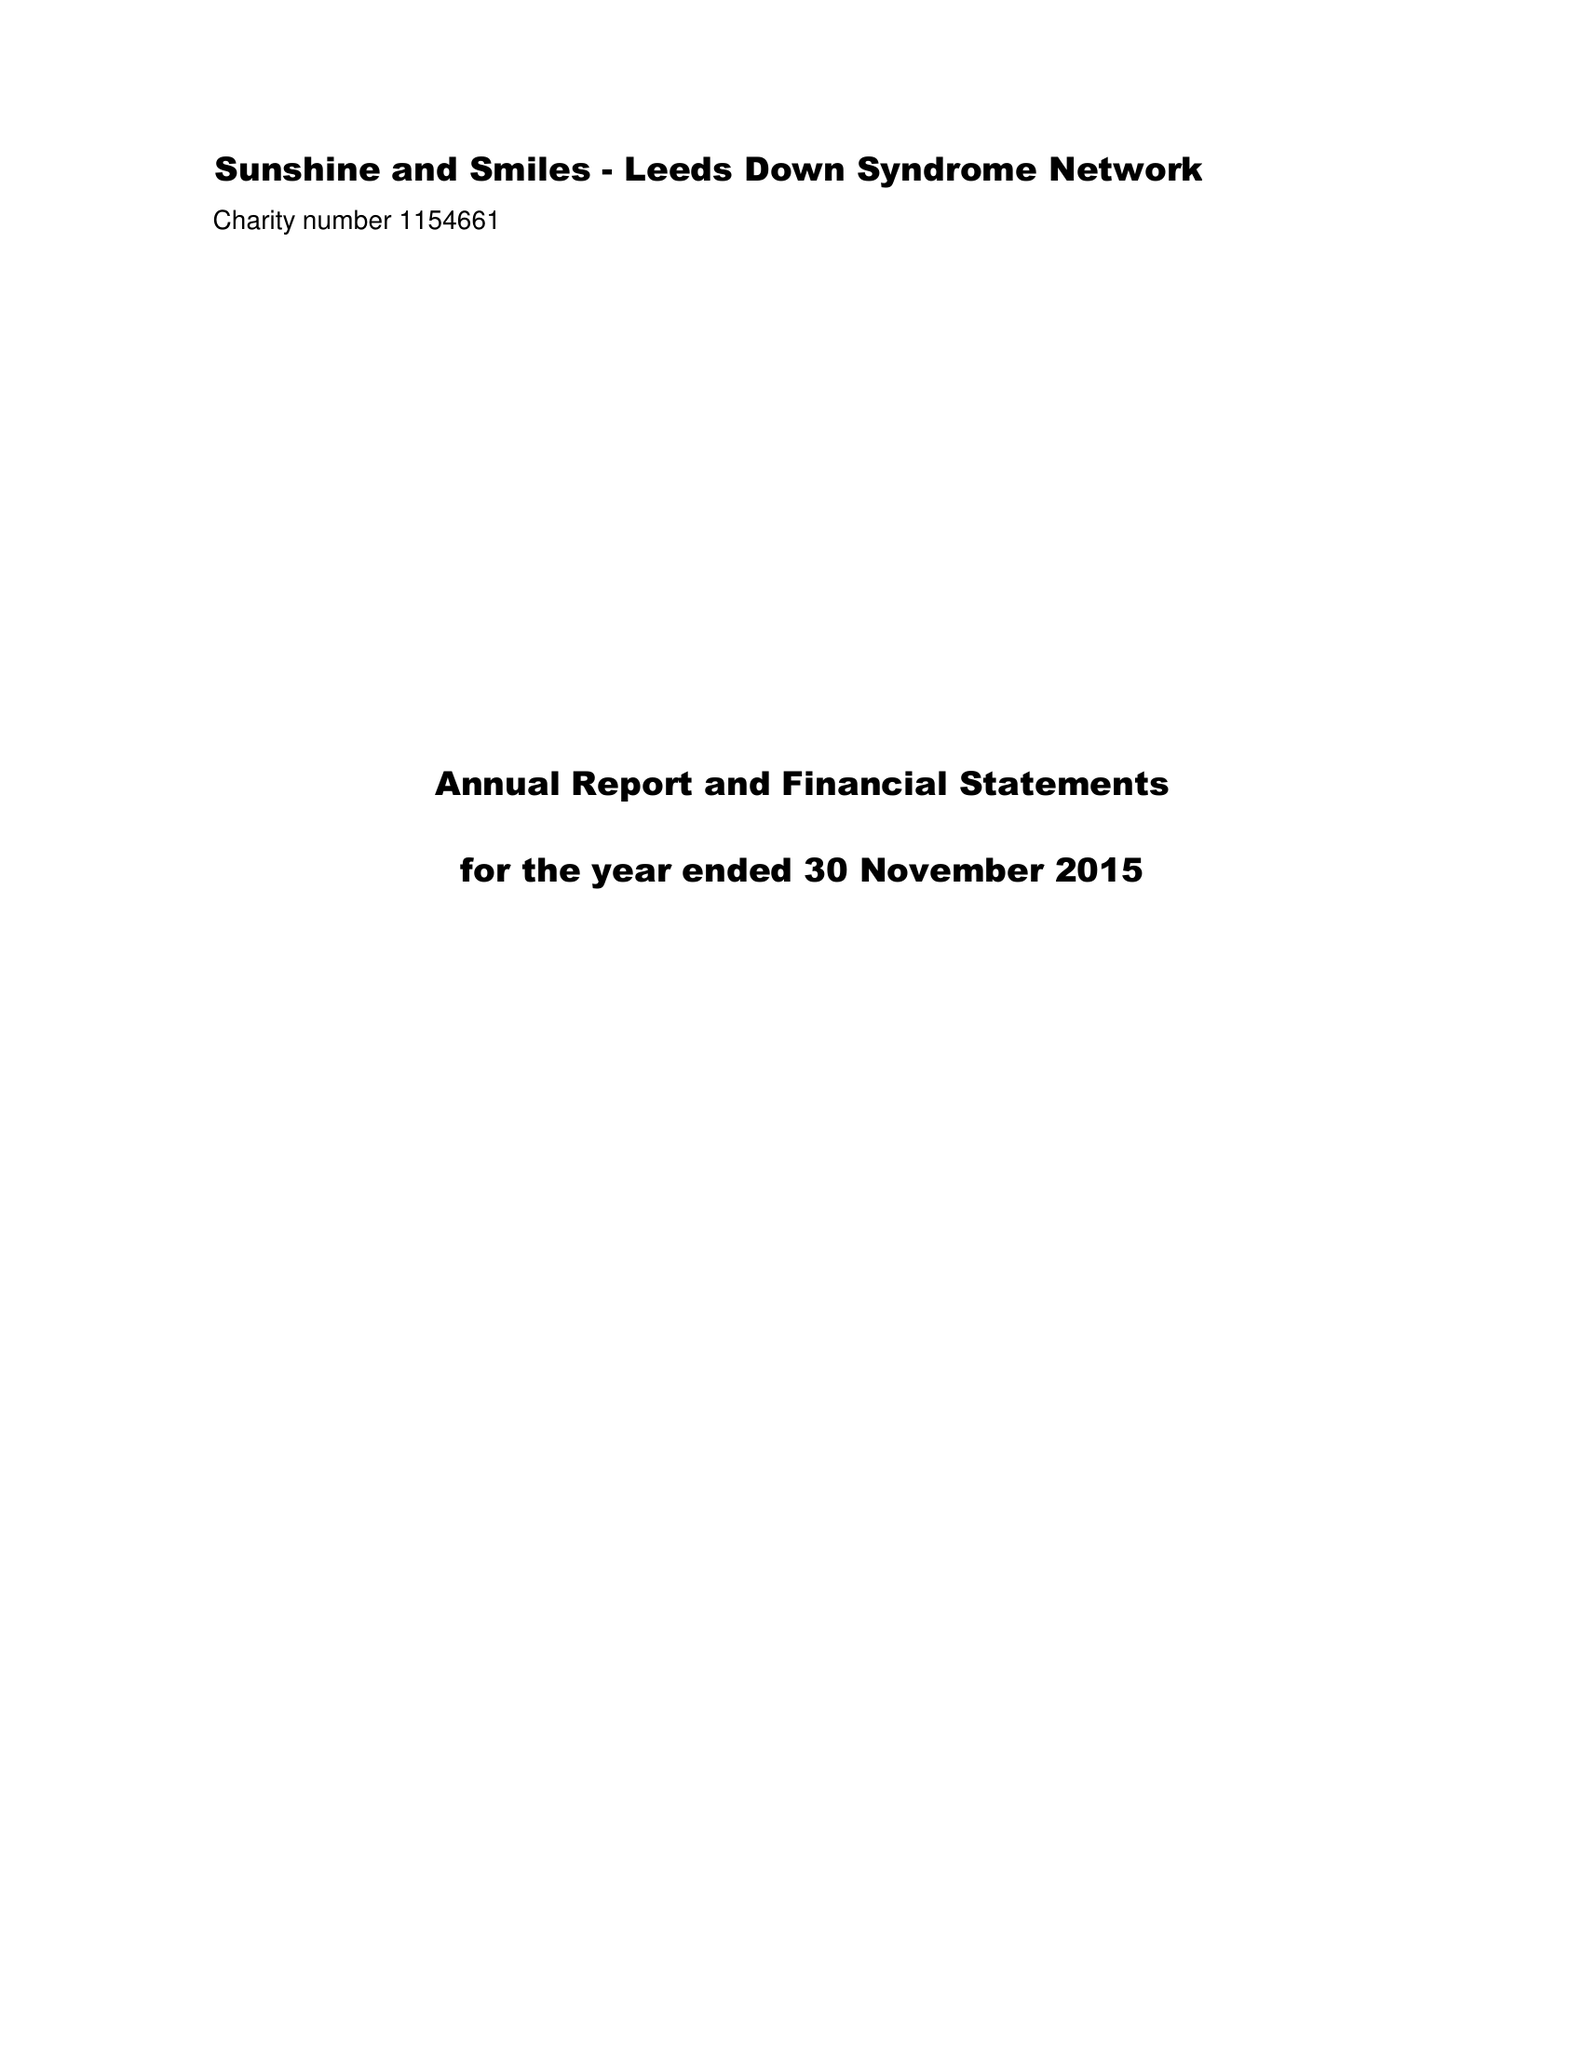What is the value for the address__postcode?
Answer the question using a single word or phrase. LS16 5LB 